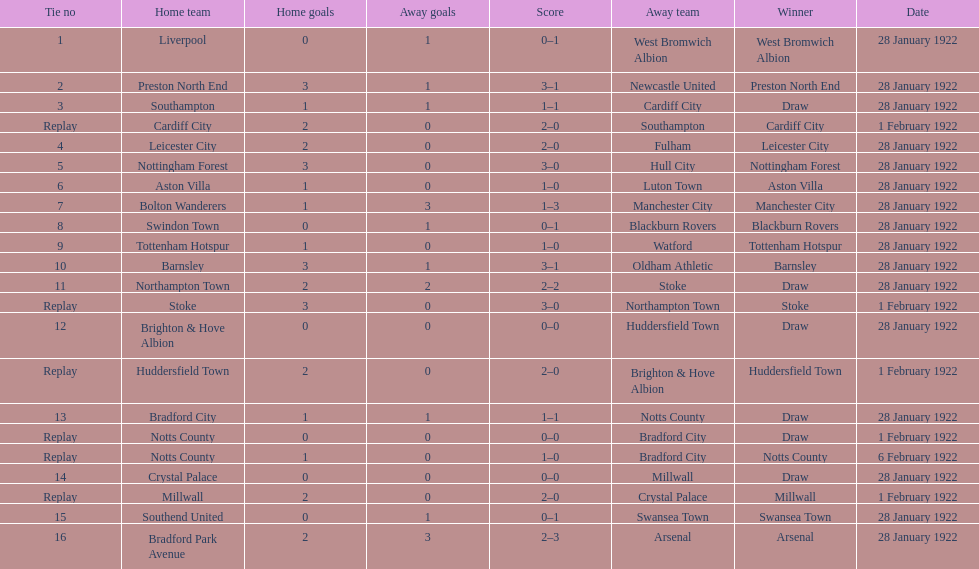What is the number of points scored on 6 february 1922? 1. 